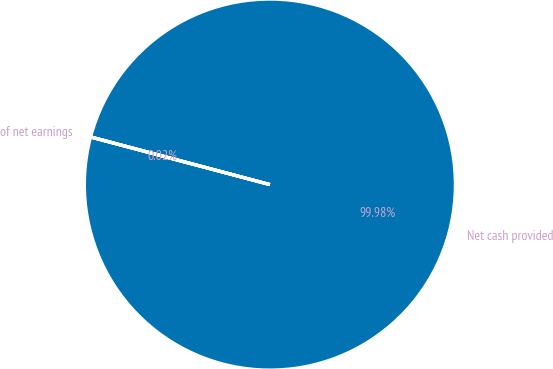<chart> <loc_0><loc_0><loc_500><loc_500><pie_chart><fcel>Net cash provided<fcel>of net earnings<nl><fcel>99.98%<fcel>0.02%<nl></chart> 